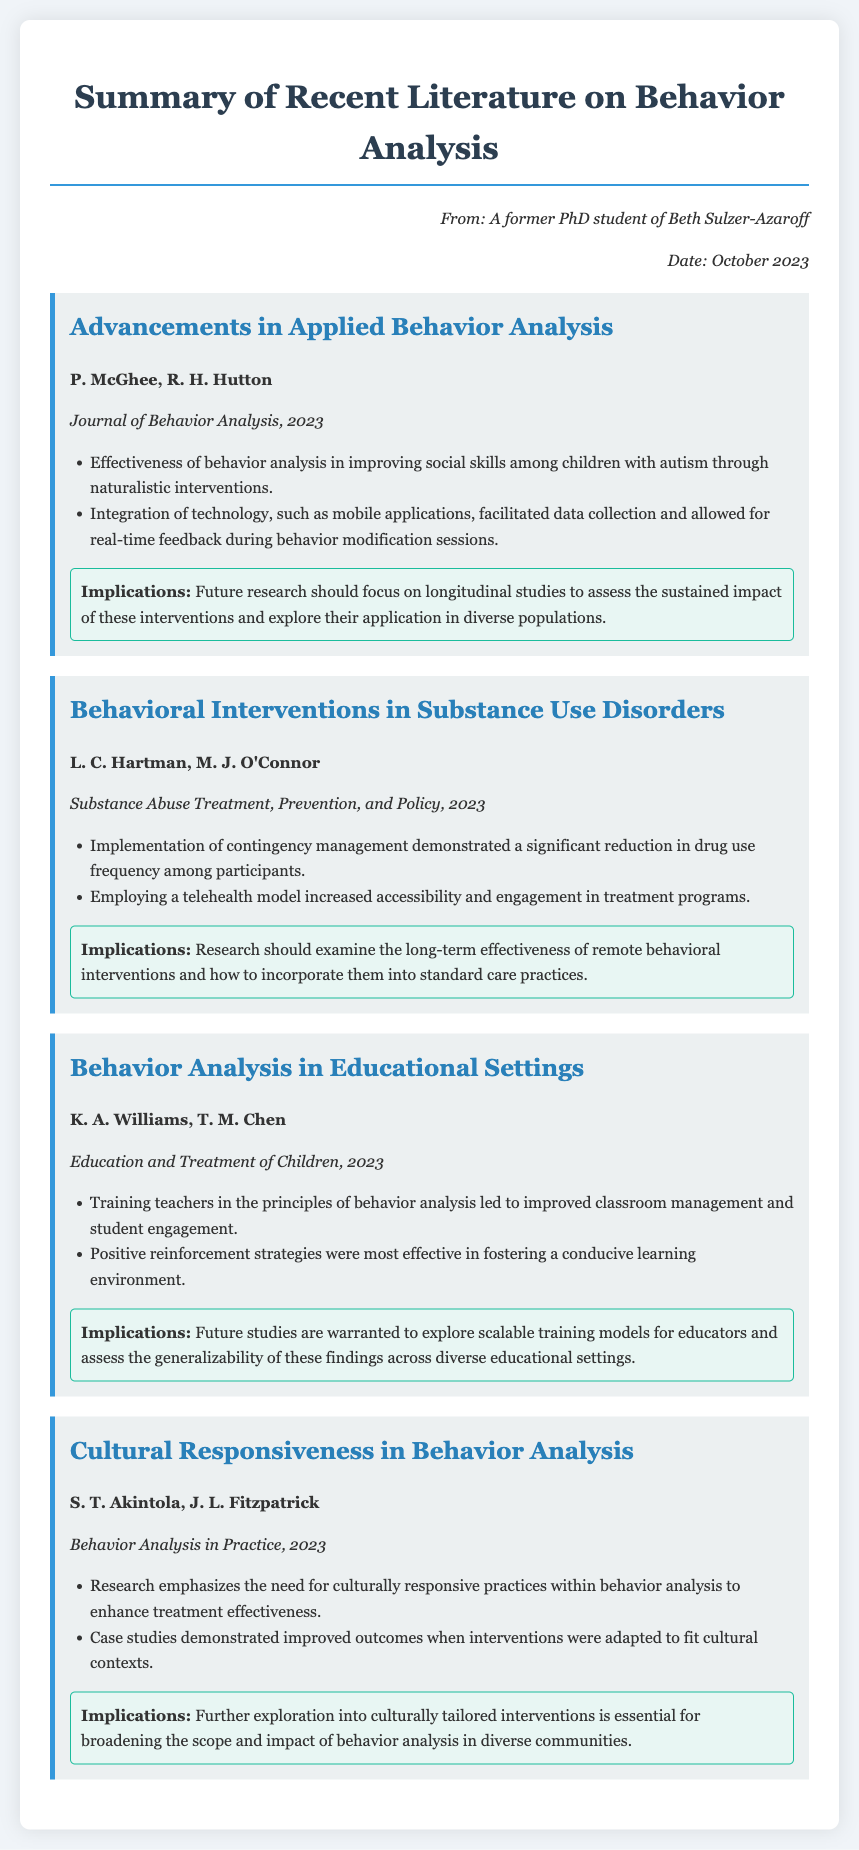what are the authors of the study "Advancements in Applied Behavior Analysis"? The authors of the study are P. McGhee and R. H. Hutton, as indicated in the document.
Answer: P. McGhee, R. H. Hutton what is the year of publication for the article on behavioral interventions in substance use disorders? The year of publication for the article is stated in the document as 2023.
Answer: 2023 which journal published the study on educational settings? The study on educational settings is published in "Education and Treatment of Children" as mentioned in the document.
Answer: Education and Treatment of Children what is one finding from the "Cultural Responsiveness in Behavior Analysis" study? One finding from the study indicates that culturally responsive practices improve treatment effectiveness, as noted in the document.
Answer: Culturally responsive practices improve treatment effectiveness what implication is suggested for future research in the study about behavioral interventions in substance use disorders? The implication suggests examining the long-term effectiveness of remote behavioral interventions, as highlighted in the document.
Answer: Examine long-term effectiveness of remote behavioral interventions how many studies are summarized in the document? The document summarizes four studies, as seen in the structure of the memo.
Answer: Four studies what type of analysis does the study by K. A. Williams and T. M. Chen focus on? The study focuses on behavior analysis in educational settings, as detailed in the document.
Answer: Behavior analysis in educational settings which methodological approach was highlighted in "Advancements in Applied Behavior Analysis"? The methodological approach highlighted is the integration of technology such as mobile applications for data collection, according to the document.
Answer: Integration of technology such as mobile applications 